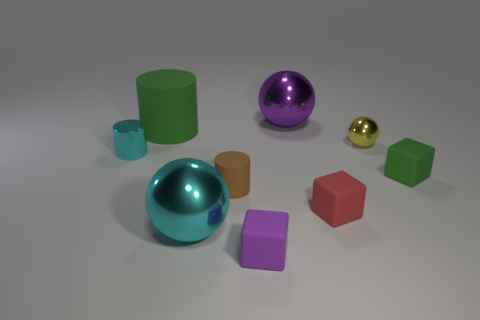Subtract all green matte cubes. How many cubes are left? 2 Add 1 big purple balls. How many objects exist? 10 Subtract all spheres. How many objects are left? 6 Subtract all cyan shiny objects. Subtract all shiny cylinders. How many objects are left? 6 Add 8 brown matte things. How many brown matte things are left? 9 Add 9 small green things. How many small green things exist? 10 Subtract 0 blue cylinders. How many objects are left? 9 Subtract all brown balls. Subtract all yellow blocks. How many balls are left? 3 